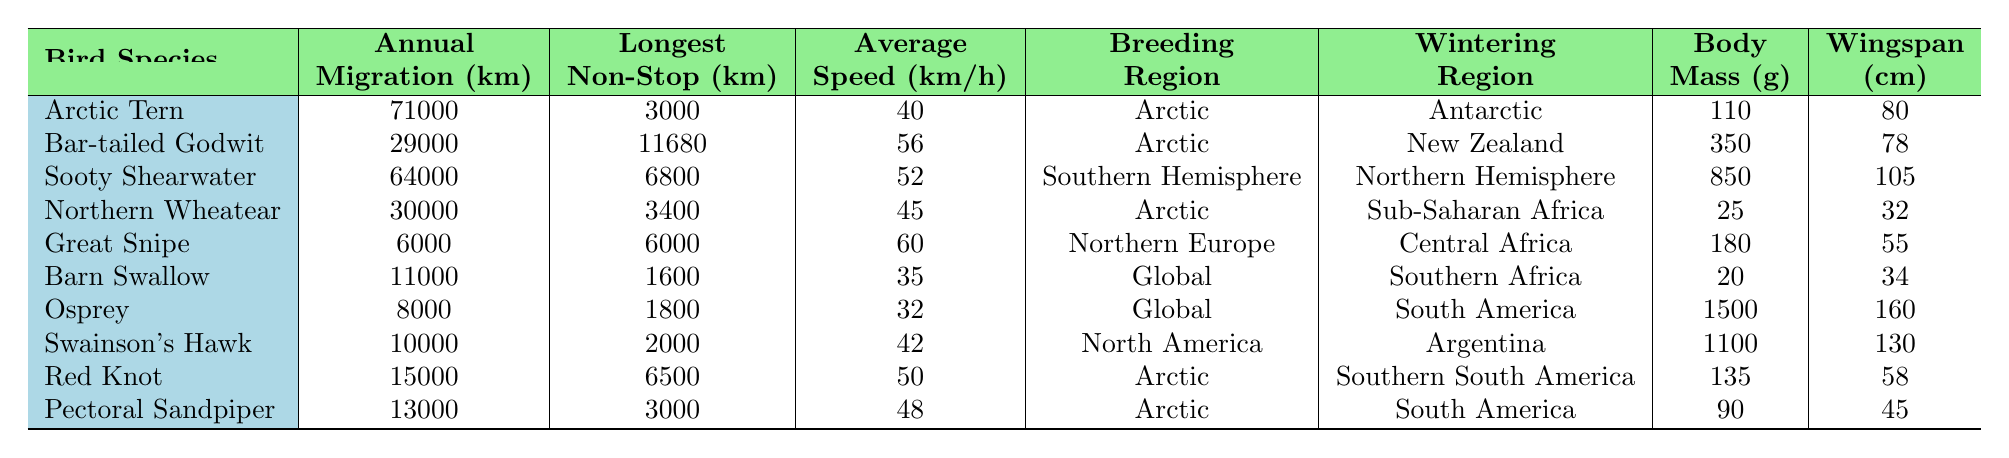What is the annual migration distance of the Arctic Tern? The Arctic Tern has an annual migration distance listed in the table as 71,000 km.
Answer: 71,000 km Which bird species has the longest non-stop flight? The Bar-tailed Godwit has the longest non-stop flight recorded in the table at 11,680 km.
Answer: Bar-tailed Godwit What is the average flight speed of the Sooty Shearwater? The average flight speed of the Sooty Shearwater is 52 km/h as indicated in the table.
Answer: 52 km/h How many birds have an annual migration distance greater than 20,000 km? The Arctic Tern, Sooty Shearwater, Bar-tailed Godwit, and Northern Wheatear are the species with distances over 20,000 km, which totals four species.
Answer: 4 Is the Great Snipe heavier than the Barn Swallow? The Great Snipe has a body mass of 180 g while the Barn Swallow weighs only 20 g, so yes, the Great Snipe is heavier.
Answer: Yes Which bird species breeds in the Arctic and winters in South America? The Osprey is the only species that breeds in the Arctic and winters in South America based on the regions listed in the table.
Answer: Osprey Calculate the average wingspan of all the birds in the table. The wingspan values are 80, 78, 105, 32, 55, 34, 160, 130, 58, and 45 cm. The sum is 80 + 78 + 105 + 32 + 55 + 34 + 160 + 130 + 58 + 45 = 787 cm. Dividing this by the number of birds (10), the average wingspan is 78.7 cm.
Answer: 78.7 cm What is the body mass difference between the lightest and heaviest bird? The lightest bird is the Barn Swallow at 20 g and the heaviest is the Osprey at 1500 g. The difference is 1500 - 20 = 1480 g.
Answer: 1480 g Are there any bird species that have a longest non-stop flight greater than 5000 km? The Bar-tailed Godwit (11680 km) and the Red Knot (6500 km) both have longest non-stop flights greater than 5000 km; therefore, the answer is yes.
Answer: Yes Which two species have the same longest non-stop flight distance? The Great Snipe and Pectoral Sandpiper both have a longest non-stop flight distance of 6000 km.
Answer: Great Snipe, Pectoral Sandpiper 